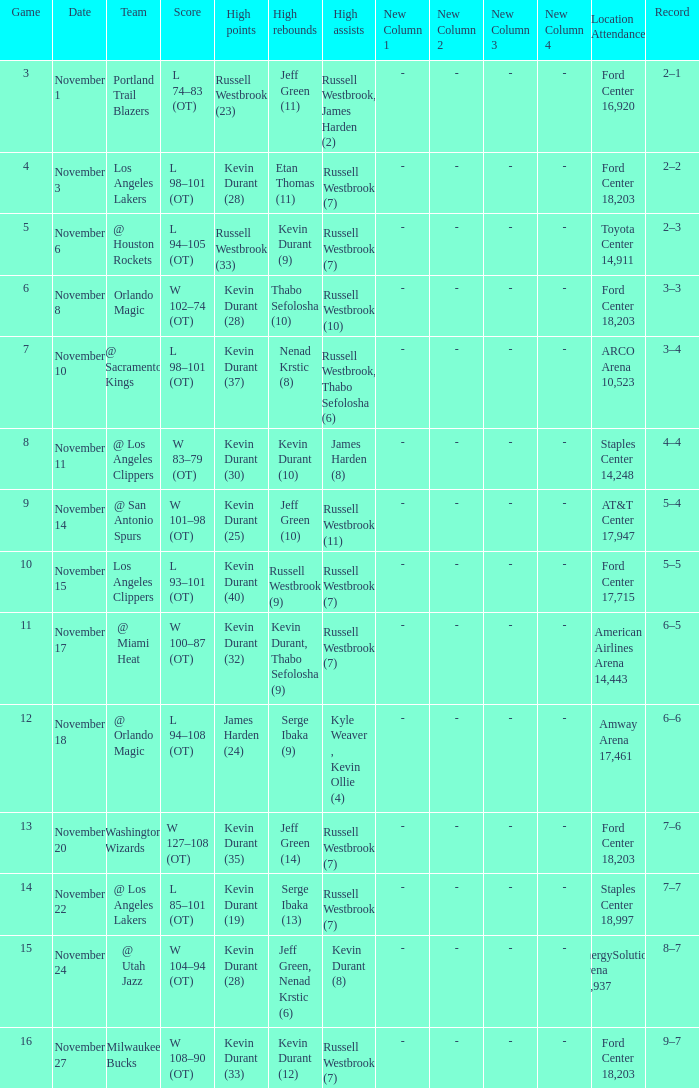What was the record in the game in which Jeff Green (14) did the most high rebounds? 7–6. 